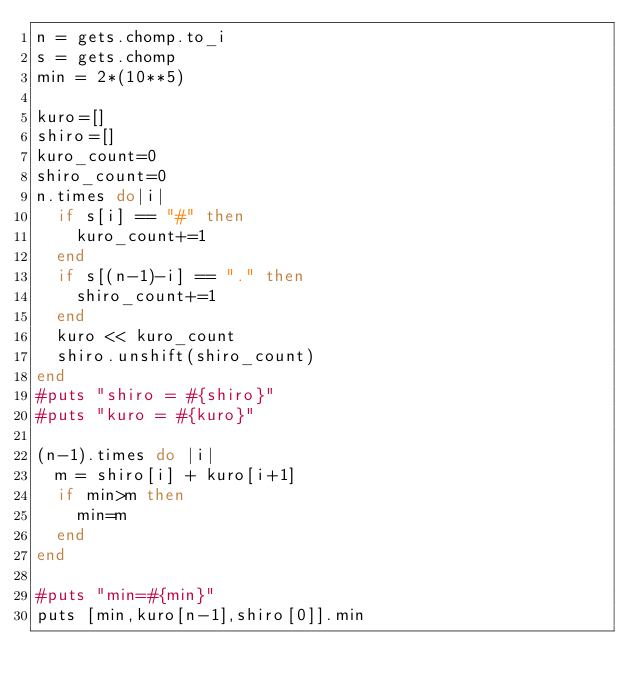<code> <loc_0><loc_0><loc_500><loc_500><_Ruby_>n = gets.chomp.to_i
s = gets.chomp
min = 2*(10**5)

kuro=[]
shiro=[]
kuro_count=0
shiro_count=0
n.times do|i|
  if s[i] == "#" then
    kuro_count+=1 
  end
  if s[(n-1)-i] == "." then
    shiro_count+=1
  end
  kuro << kuro_count
  shiro.unshift(shiro_count)
end
#puts "shiro = #{shiro}"
#puts "kuro = #{kuro}"

(n-1).times do |i|
  m = shiro[i] + kuro[i+1]
  if min>m then
    min=m
  end
end

#puts "min=#{min}"
puts [min,kuro[n-1],shiro[0]].min


</code> 